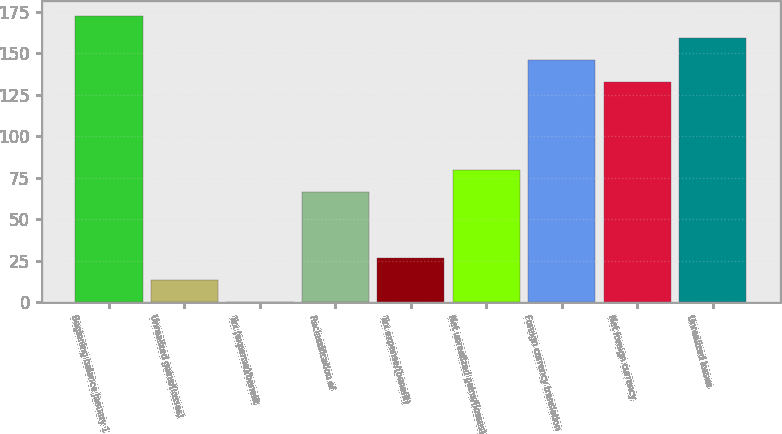Convert chart to OTSL. <chart><loc_0><loc_0><loc_500><loc_500><bar_chart><fcel>Beginning balance January 1<fcel>Unrealized gains/(losses)<fcel>Tax (expense)/benefit<fcel>Reclassification of<fcel>Tax expense/(benefit)<fcel>Net unrealized gains/(losses)<fcel>Foreign currency translation<fcel>Net foreign currency<fcel>Unrealized losses<nl><fcel>172.61<fcel>13.37<fcel>0.1<fcel>66.45<fcel>26.64<fcel>79.72<fcel>146.07<fcel>132.8<fcel>159.34<nl></chart> 